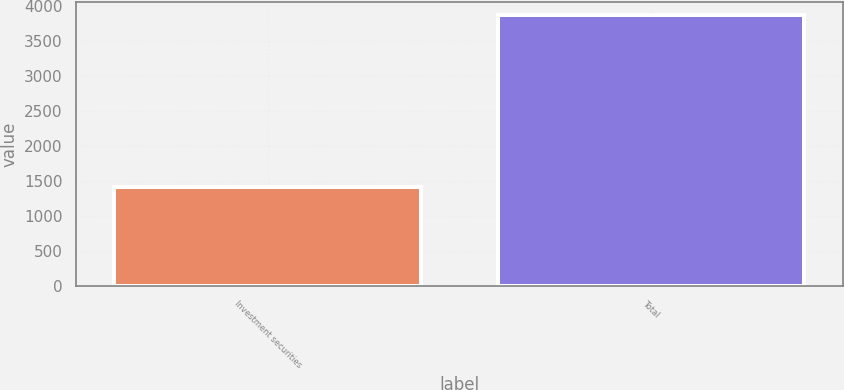Convert chart. <chart><loc_0><loc_0><loc_500><loc_500><bar_chart><fcel>Investment securities<fcel>Total<nl><fcel>1422<fcel>3872<nl></chart> 